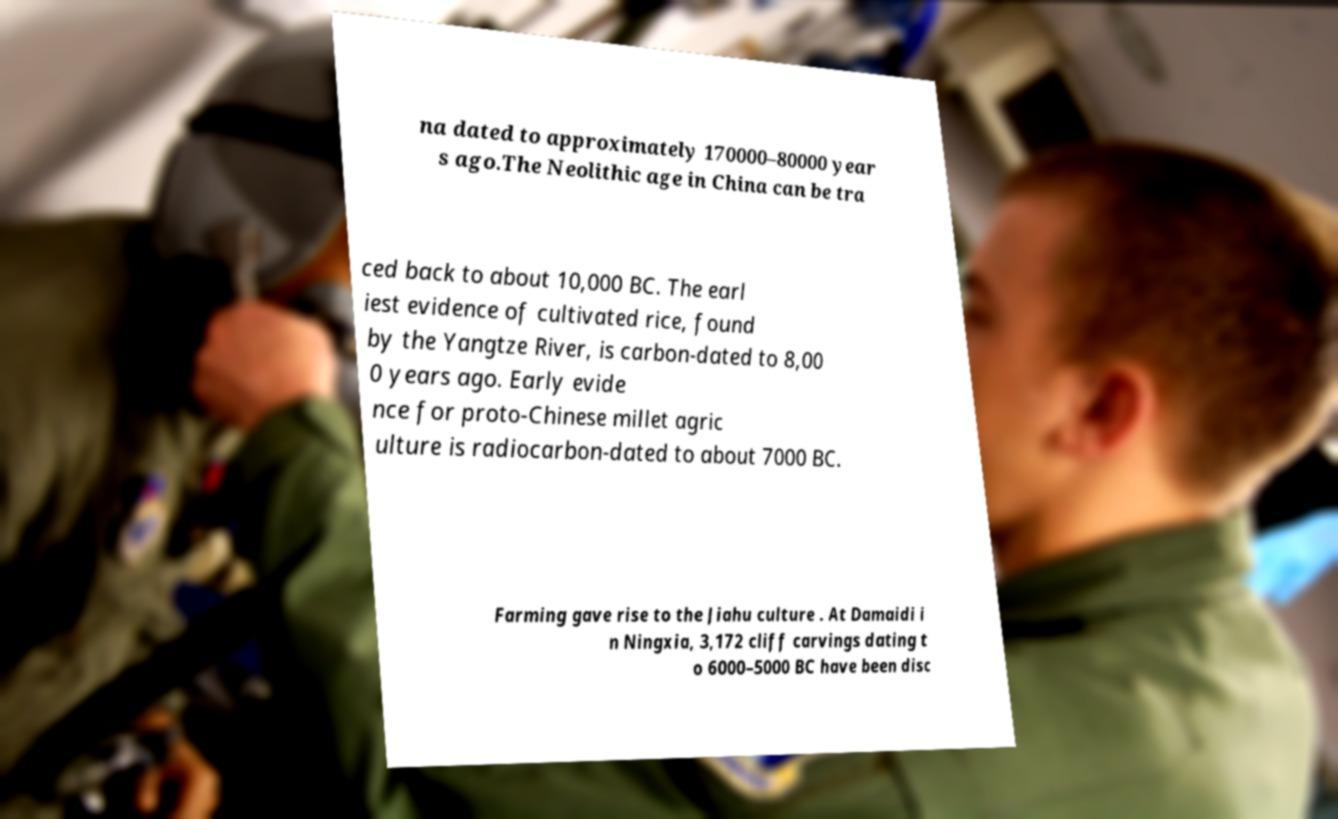Could you extract and type out the text from this image? na dated to approximately 170000–80000 year s ago.The Neolithic age in China can be tra ced back to about 10,000 BC. The earl iest evidence of cultivated rice, found by the Yangtze River, is carbon-dated to 8,00 0 years ago. Early evide nce for proto-Chinese millet agric ulture is radiocarbon-dated to about 7000 BC. Farming gave rise to the Jiahu culture . At Damaidi i n Ningxia, 3,172 cliff carvings dating t o 6000–5000 BC have been disc 